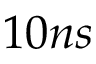<formula> <loc_0><loc_0><loc_500><loc_500>1 0 n s</formula> 